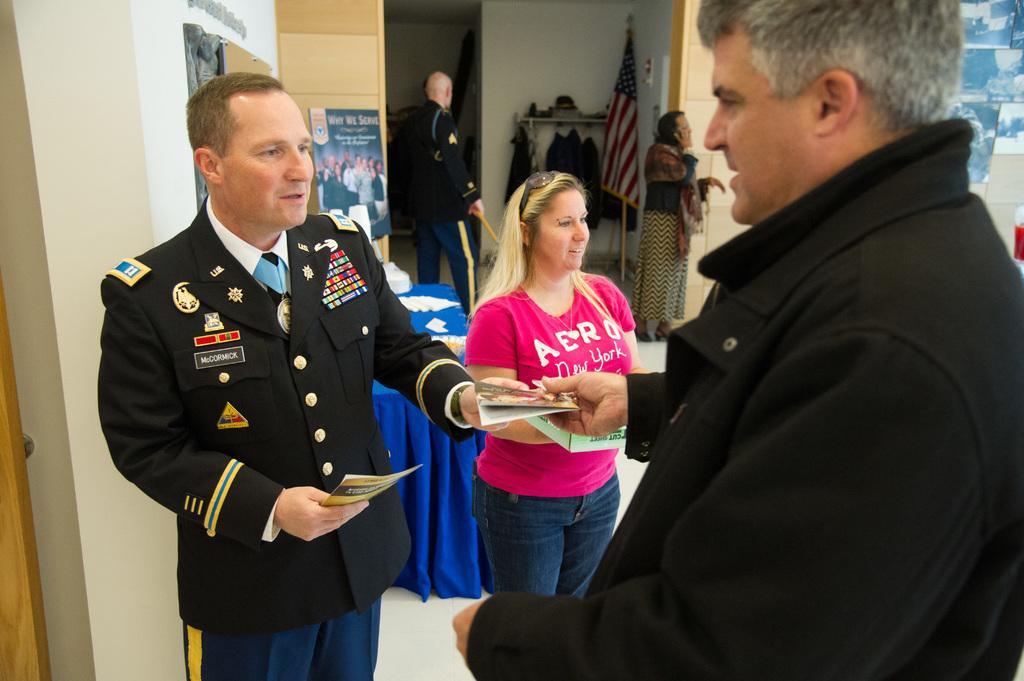Describe this image in one or two sentences. In this picture we can see a few people holding objects in their hands. We can see a woman wearing goggles. There are a few things kept on a table. We can see a poster, flag, clothes on hanging rods, few people and other objects visible in the background. We can see a wooden object on the left side. 